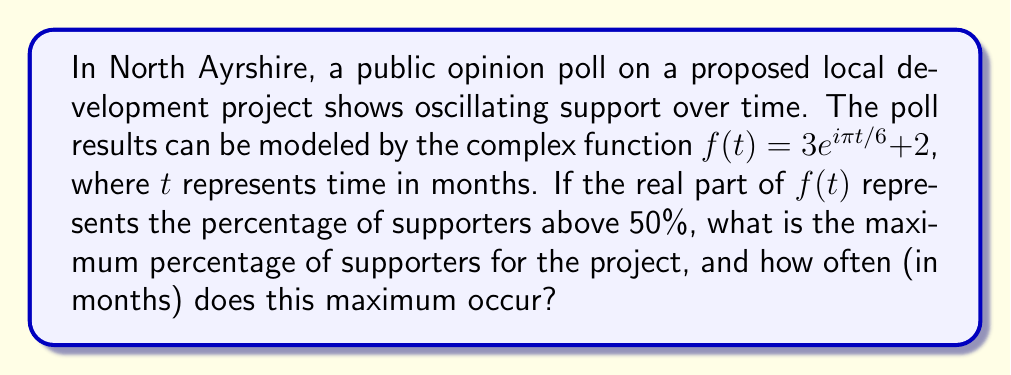Provide a solution to this math problem. Let's approach this step-by-step:

1) The function $f(t) = 3e^{i\pi t/6} + 2$ can be rewritten using Euler's formula:
   $f(t) = 3(\cos(\pi t/6) + i\sin(\pi t/6)) + 2$

2) The real part of this function represents the percentage of supporters above 50%:
   $\text{Re}(f(t)) = 3\cos(\pi t/6) + 2$

3) To find the maximum value, we need to find when $\cos(\pi t/6)$ is at its maximum, which is 1.

4) When $\cos(\pi t/6) = 1$, the function reaches its maximum:
   $\text{Max}(\text{Re}(f(t))) = 3(1) + 2 = 5$

5) This means the maximum percentage above 50% is 5%, so the actual maximum percentage of supporters is 55%.

6) To find how often this maximum occurs, we need to find the period of the cosine function:
   $\text{Period} = \frac{2\pi}{\frac{\pi}{6}} = 12$ months

Therefore, the maximum occurs every 12 months.
Answer: 55%; every 12 months 